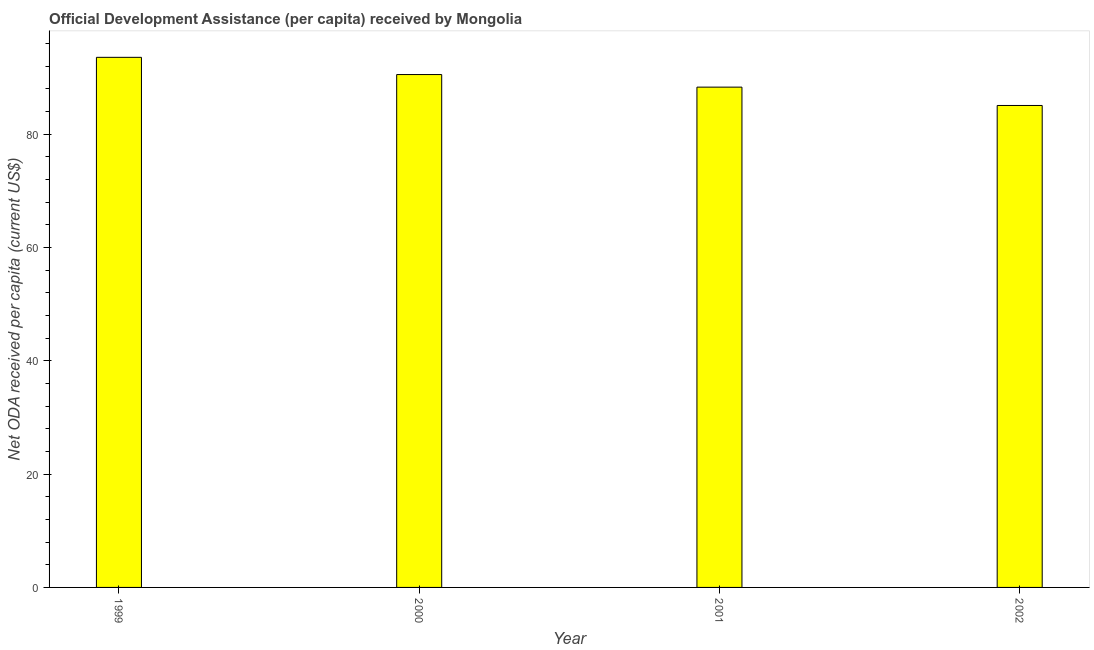What is the title of the graph?
Offer a very short reply. Official Development Assistance (per capita) received by Mongolia. What is the label or title of the Y-axis?
Your answer should be compact. Net ODA received per capita (current US$). What is the net oda received per capita in 2001?
Offer a terse response. 88.28. Across all years, what is the maximum net oda received per capita?
Provide a succinct answer. 93.54. Across all years, what is the minimum net oda received per capita?
Offer a very short reply. 85.04. In which year was the net oda received per capita maximum?
Offer a terse response. 1999. What is the sum of the net oda received per capita?
Provide a succinct answer. 357.35. What is the difference between the net oda received per capita in 2001 and 2002?
Give a very brief answer. 3.24. What is the average net oda received per capita per year?
Give a very brief answer. 89.34. What is the median net oda received per capita?
Provide a succinct answer. 89.39. In how many years, is the net oda received per capita greater than 24 US$?
Your answer should be compact. 4. Do a majority of the years between 1999 and 2002 (inclusive) have net oda received per capita greater than 84 US$?
Your response must be concise. Yes. What is the ratio of the net oda received per capita in 1999 to that in 2000?
Offer a terse response. 1.03. What is the difference between the highest and the second highest net oda received per capita?
Your response must be concise. 3.04. Is the sum of the net oda received per capita in 1999 and 2001 greater than the maximum net oda received per capita across all years?
Your answer should be compact. Yes. Are all the bars in the graph horizontal?
Provide a succinct answer. No. What is the difference between two consecutive major ticks on the Y-axis?
Offer a terse response. 20. Are the values on the major ticks of Y-axis written in scientific E-notation?
Provide a succinct answer. No. What is the Net ODA received per capita (current US$) of 1999?
Offer a terse response. 93.54. What is the Net ODA received per capita (current US$) in 2000?
Ensure brevity in your answer.  90.5. What is the Net ODA received per capita (current US$) of 2001?
Offer a very short reply. 88.28. What is the Net ODA received per capita (current US$) in 2002?
Give a very brief answer. 85.04. What is the difference between the Net ODA received per capita (current US$) in 1999 and 2000?
Provide a succinct answer. 3.04. What is the difference between the Net ODA received per capita (current US$) in 1999 and 2001?
Your answer should be very brief. 5.26. What is the difference between the Net ODA received per capita (current US$) in 1999 and 2002?
Offer a very short reply. 8.5. What is the difference between the Net ODA received per capita (current US$) in 2000 and 2001?
Provide a short and direct response. 2.22. What is the difference between the Net ODA received per capita (current US$) in 2000 and 2002?
Your answer should be very brief. 5.45. What is the difference between the Net ODA received per capita (current US$) in 2001 and 2002?
Your response must be concise. 3.24. What is the ratio of the Net ODA received per capita (current US$) in 1999 to that in 2000?
Your response must be concise. 1.03. What is the ratio of the Net ODA received per capita (current US$) in 1999 to that in 2001?
Give a very brief answer. 1.06. What is the ratio of the Net ODA received per capita (current US$) in 1999 to that in 2002?
Provide a succinct answer. 1.1. What is the ratio of the Net ODA received per capita (current US$) in 2000 to that in 2001?
Keep it short and to the point. 1.02. What is the ratio of the Net ODA received per capita (current US$) in 2000 to that in 2002?
Keep it short and to the point. 1.06. What is the ratio of the Net ODA received per capita (current US$) in 2001 to that in 2002?
Keep it short and to the point. 1.04. 